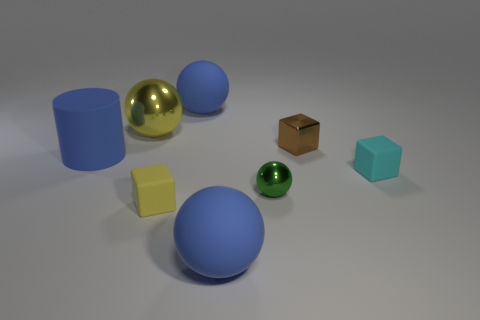Subtract all brown balls. Subtract all purple cylinders. How many balls are left? 4 Add 1 tiny yellow cubes. How many objects exist? 9 Subtract all blocks. How many objects are left? 5 Subtract 1 blue cylinders. How many objects are left? 7 Subtract all shiny spheres. Subtract all large purple cubes. How many objects are left? 6 Add 2 tiny yellow objects. How many tiny yellow objects are left? 3 Add 1 rubber things. How many rubber things exist? 6 